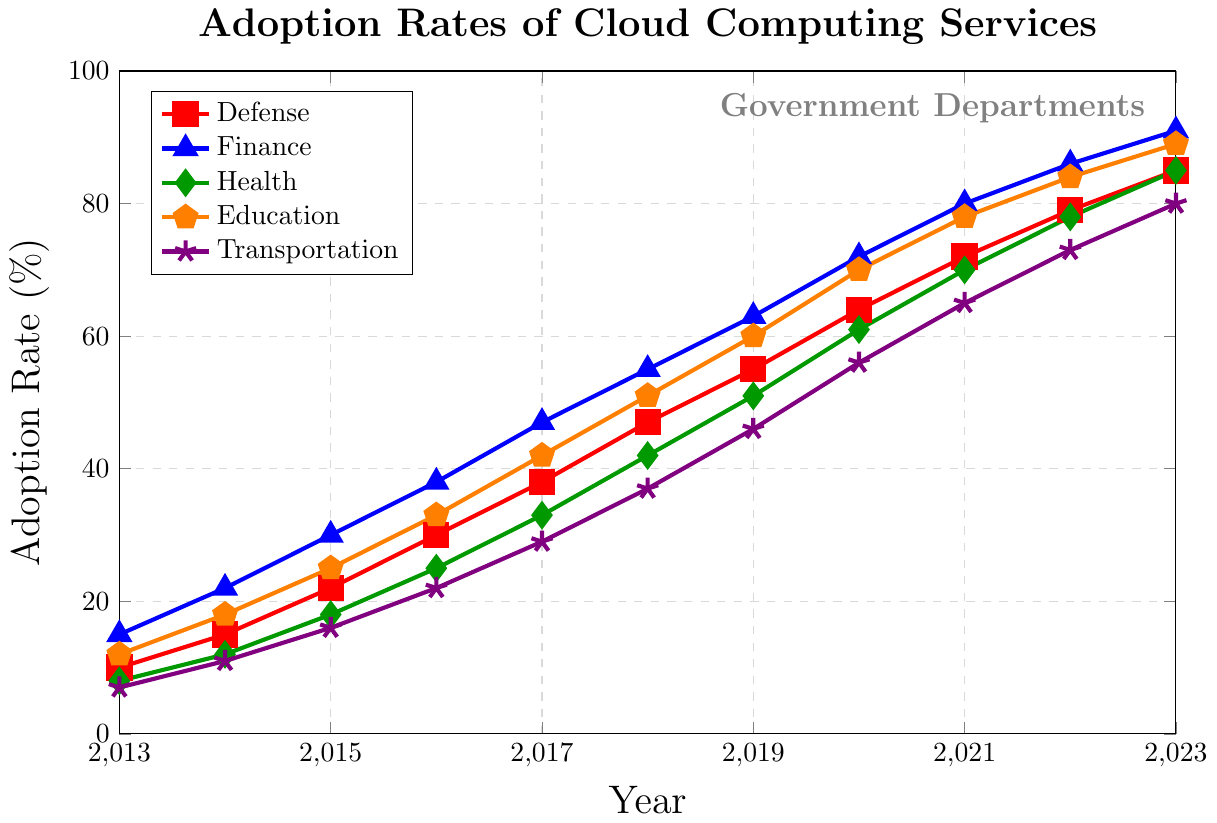Which department had the highest adoption rate in 2018? Look at the y-values for 2018 for each department and compare them. Finance had the highest value at 55%.
Answer: Finance What is the difference in the adoption rate between Defense and Health in 2023? Find the adoption rates of Defense and Health in 2023 (85% and 85%, respectively) and subtract the smaller from the larger (85 - 85 = 0).
Answer: 0% Which department saw the largest growth in adoption rate between 2013 and 2023? Calculate the growth for each department by subtracting the 2013 rates from the 2023 rates: Defense (85-10=75), Finance (91-15=76), Health (85-8=77), Education (89-12=77), Transportation (80-7=73). Health and Education both grew by 77%.
Answer: Health and Education Between which consecutive years did Education see the largest increase in adoption rate? Calculate the year-over-year differences for Education: (18-12)=6, (25-18)=7, (33-25)=8, (42-33)=9, (51-42)=9, (60-51)=9, (70-60)=10, (78-70)=8, (84-78)=6, (89-84)=5. The largest increase was between 2019 and 2020 (10).
Answer: 2019 to 2020 By the end of 2020, what was the total adoption rate of the Finance and Transportation departments combined? Add the adoption rates for Finance and Transportation in 2020: 72% for Finance and 56% for Transportation (72 + 56 = 128).
Answer: 128% Which year saw the smallest adoption rate difference between Defense and Finance departments? Calculate the year-by-year differences for Defense and Finance: 2013 (15-10=5), 2014 (22-15=7), 2015 (30-22=8), 2016 (38-30=8), 2017 (47-38=9), 2018 (55-47=8), 2019 (63-55=8), 2020 (72-64=8), 2021 (80-72=8), 2022 (86-79=7), 2023 (91-85=6). The smallest difference was in 2013, where the difference was 5.
Answer: 2013 What is the average adoption rate of Health department over the decade? Sum the annual adoption rates of Health from 2013 to 2023, then divide by the number of years: (8+12+18+25+33+42+51+61+70+78+85)/11 = 44.72% (rounded to two decimal places).
Answer: 44.72% Which color represents the department with the lowest initial adoption rate in 2013? Identify the 2013 adoption rates: Defense (10), Finance (15), Health (8), Education (12), Transportation (7). Transportation had the lowest value, which is represented by violet (mark=star).
Answer: violet What is the total increase in adoption rates for Transportation from 2016 to 2020? Find the adoption rates for Transportation in 2016 and 2020 (22% and 56%, respectively) and subtract the former from the latter (56 - 22 = 34).
Answer: 34% Which department had a consistent year-on-year increase in adoption rate with no drops from 2013 to 2023? Compare the adoption rates year by year for each department. Defense, Finance, Health, Education, and Transportation all show consistent increases with no drops in adoption rates over the given years.
Answer: All departments 